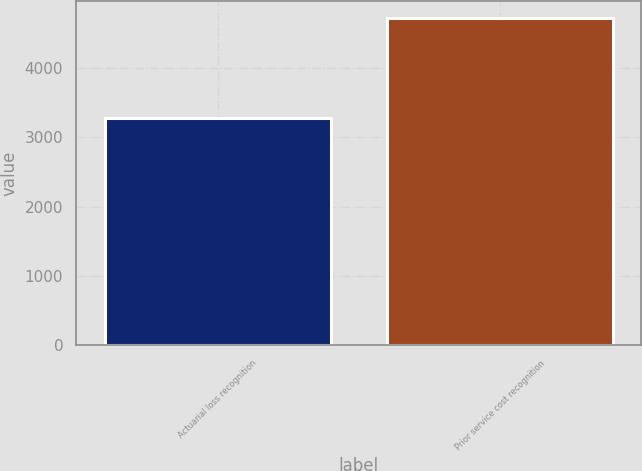<chart> <loc_0><loc_0><loc_500><loc_500><bar_chart><fcel>Actuarial loss recognition<fcel>Prior service cost recognition<nl><fcel>3277<fcel>4721<nl></chart> 